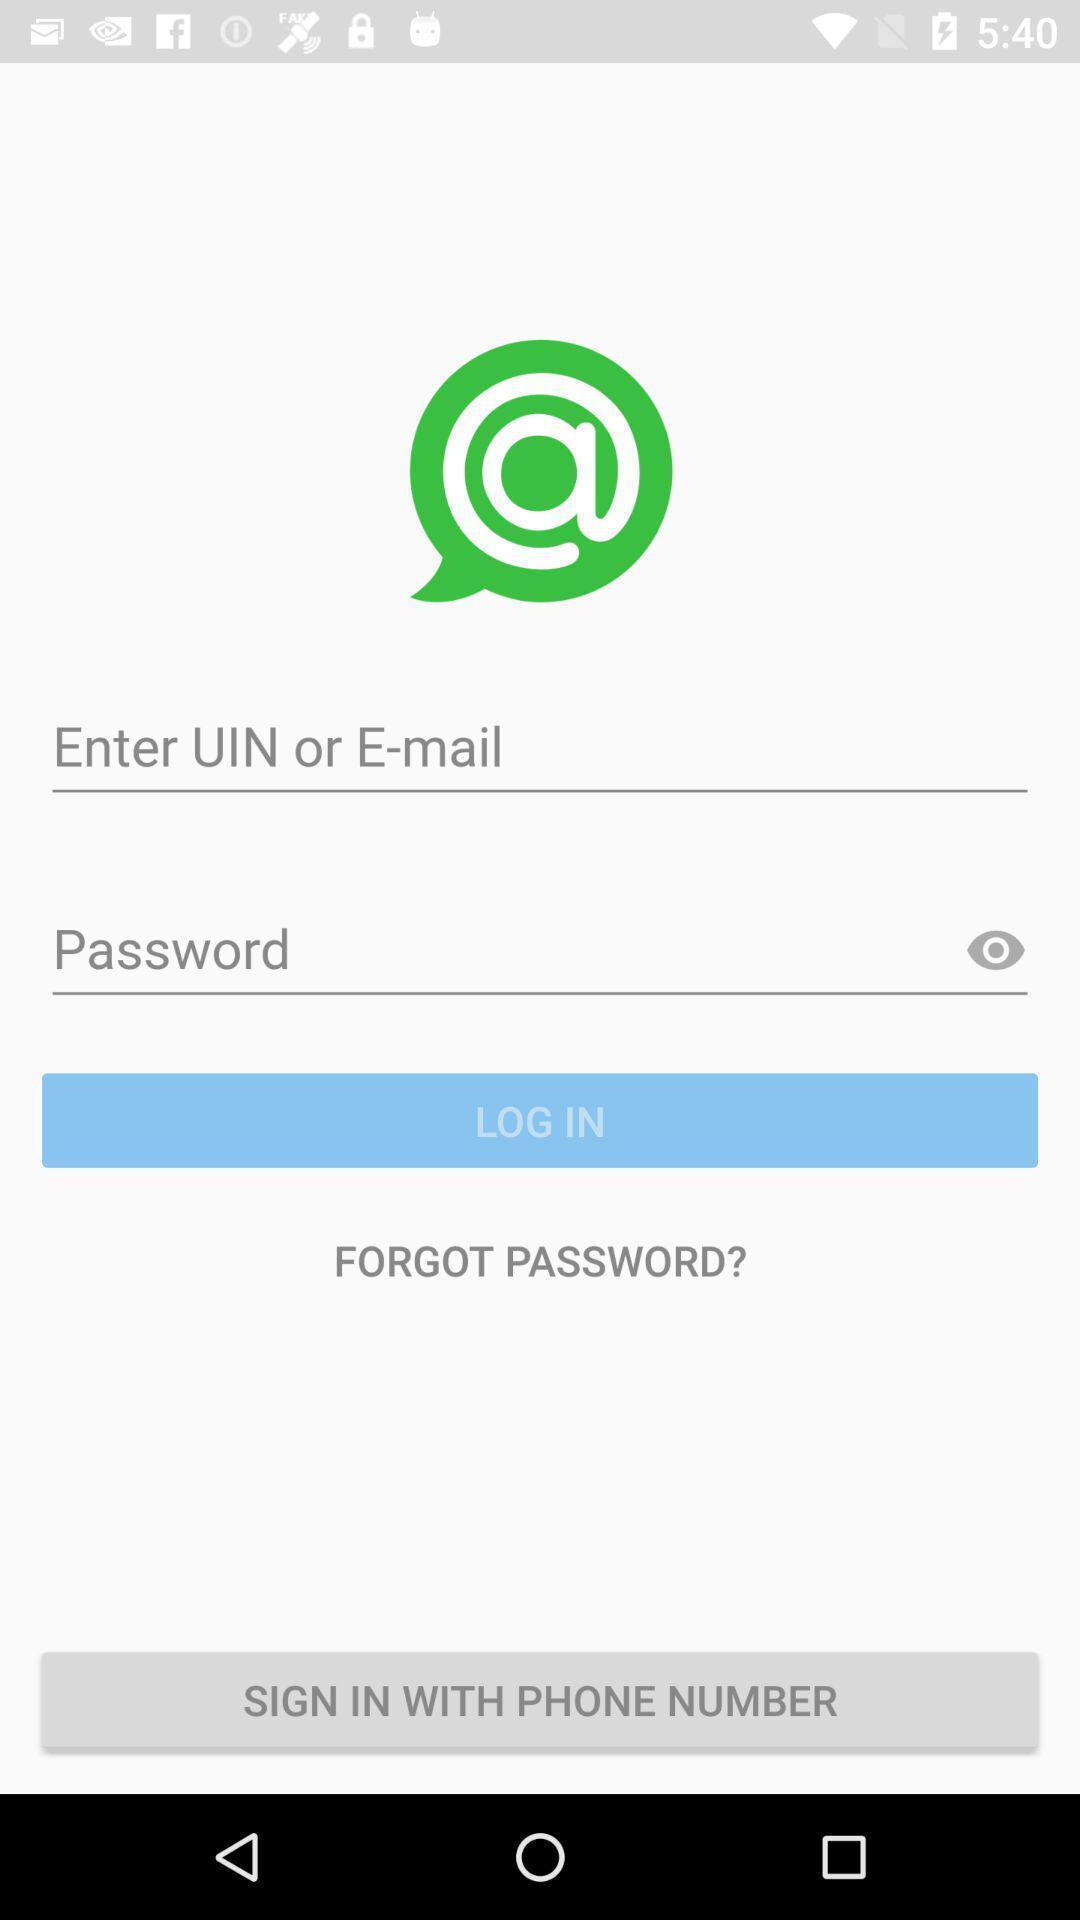Summarize the information in this screenshot. Sign-in page of a chatting app. 